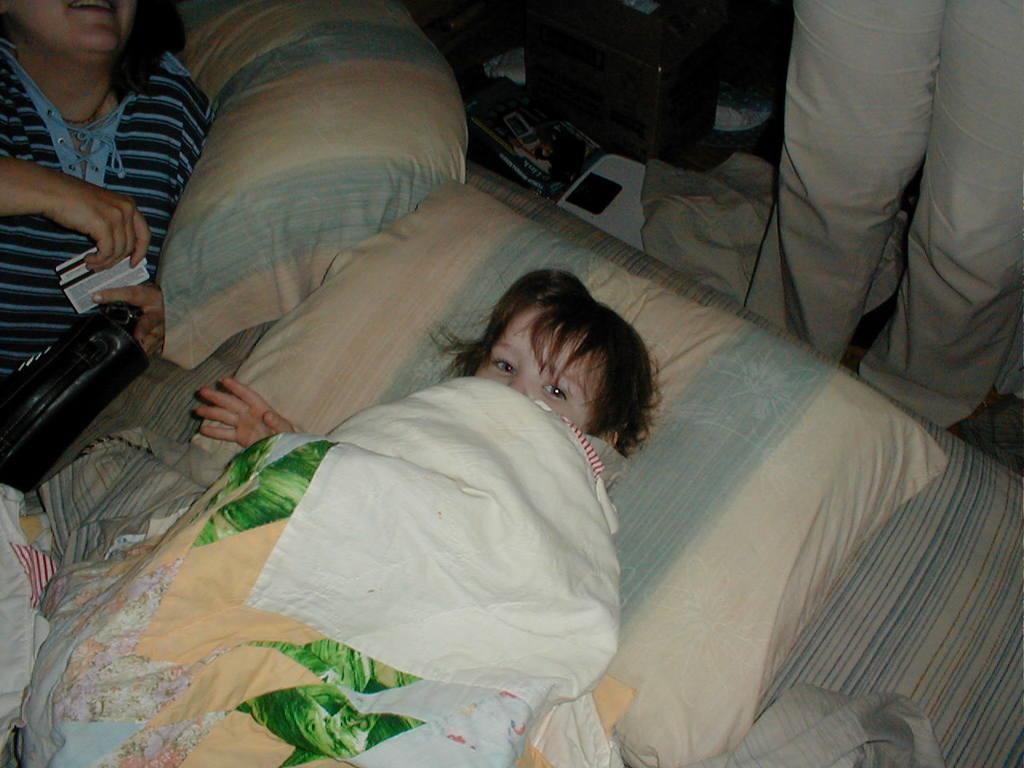Who is present in the image? There is a person and a baby in the image. What are they doing in the image? Both the person and the baby are lying on a bed. What items can be seen on the bed? There are cushions and blankets in the image. Is there anyone else in the image besides the person and the baby? Yes, there is a person standing on the right side of the image. What else can be seen in the image? There are objects visible in the image. What type of spy equipment can be seen in the image? There is no spy equipment present in the image. What design elements can be observed in the image? The question is too vague, as there are no specific design elements mentioned in the provided facts. 